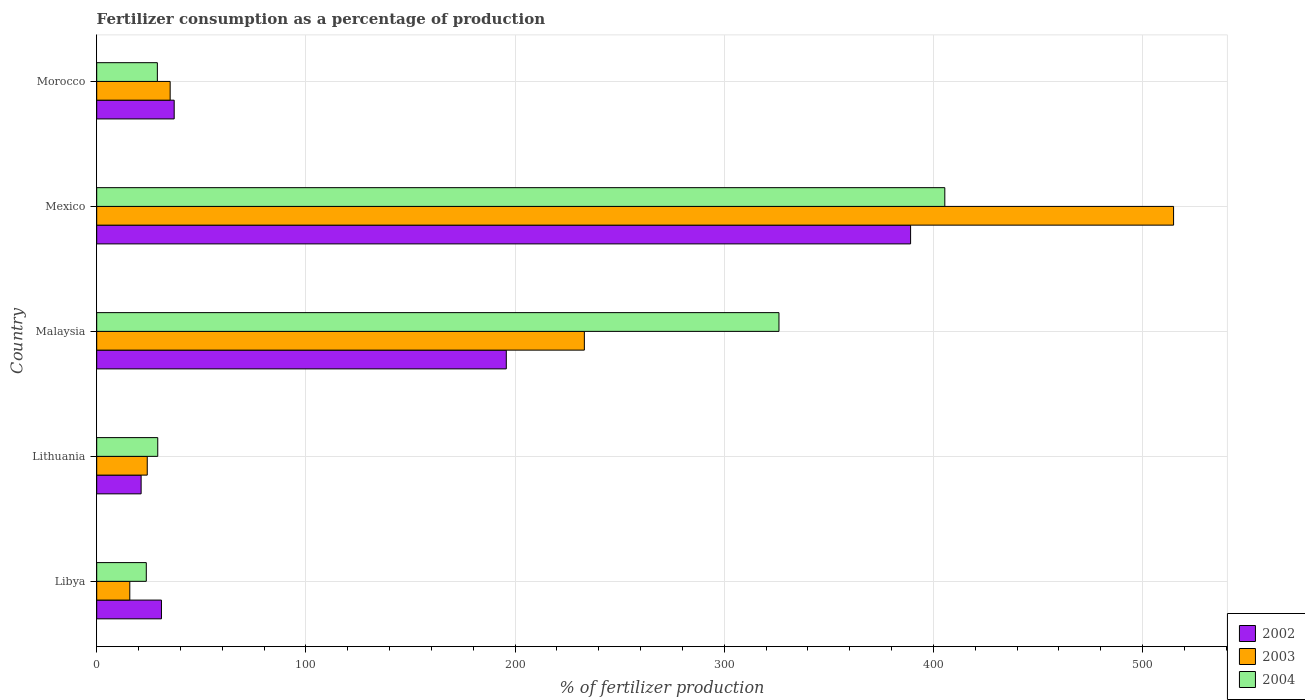Are the number of bars per tick equal to the number of legend labels?
Your response must be concise. Yes. How many bars are there on the 4th tick from the top?
Your response must be concise. 3. How many bars are there on the 3rd tick from the bottom?
Offer a terse response. 3. In how many cases, is the number of bars for a given country not equal to the number of legend labels?
Your response must be concise. 0. What is the percentage of fertilizers consumed in 2002 in Mexico?
Your response must be concise. 389.08. Across all countries, what is the maximum percentage of fertilizers consumed in 2002?
Your answer should be very brief. 389.08. Across all countries, what is the minimum percentage of fertilizers consumed in 2002?
Keep it short and to the point. 21.23. In which country was the percentage of fertilizers consumed in 2003 minimum?
Make the answer very short. Libya. What is the total percentage of fertilizers consumed in 2004 in the graph?
Provide a succinct answer. 813.48. What is the difference between the percentage of fertilizers consumed in 2003 in Lithuania and that in Malaysia?
Provide a succinct answer. -208.96. What is the difference between the percentage of fertilizers consumed in 2002 in Mexico and the percentage of fertilizers consumed in 2004 in Lithuania?
Your response must be concise. 359.9. What is the average percentage of fertilizers consumed in 2004 per country?
Your answer should be compact. 162.7. What is the difference between the percentage of fertilizers consumed in 2004 and percentage of fertilizers consumed in 2003 in Morocco?
Offer a very short reply. -6.12. In how many countries, is the percentage of fertilizers consumed in 2004 greater than 280 %?
Ensure brevity in your answer.  2. What is the ratio of the percentage of fertilizers consumed in 2002 in Lithuania to that in Malaysia?
Offer a terse response. 0.11. What is the difference between the highest and the second highest percentage of fertilizers consumed in 2002?
Your answer should be compact. 193.28. What is the difference between the highest and the lowest percentage of fertilizers consumed in 2004?
Provide a short and direct response. 381.73. In how many countries, is the percentage of fertilizers consumed in 2003 greater than the average percentage of fertilizers consumed in 2003 taken over all countries?
Provide a succinct answer. 2. What does the 2nd bar from the top in Lithuania represents?
Your response must be concise. 2003. Is it the case that in every country, the sum of the percentage of fertilizers consumed in 2002 and percentage of fertilizers consumed in 2003 is greater than the percentage of fertilizers consumed in 2004?
Your answer should be compact. Yes. How many bars are there?
Provide a succinct answer. 15. Are all the bars in the graph horizontal?
Your response must be concise. Yes. How many countries are there in the graph?
Keep it short and to the point. 5. What is the difference between two consecutive major ticks on the X-axis?
Provide a succinct answer. 100. Are the values on the major ticks of X-axis written in scientific E-notation?
Provide a succinct answer. No. Where does the legend appear in the graph?
Offer a terse response. Bottom right. How many legend labels are there?
Offer a terse response. 3. How are the legend labels stacked?
Ensure brevity in your answer.  Vertical. What is the title of the graph?
Offer a very short reply. Fertilizer consumption as a percentage of production. Does "1990" appear as one of the legend labels in the graph?
Provide a succinct answer. No. What is the label or title of the X-axis?
Make the answer very short. % of fertilizer production. What is the % of fertilizer production in 2002 in Libya?
Your answer should be compact. 30.95. What is the % of fertilizer production of 2003 in Libya?
Ensure brevity in your answer.  15.82. What is the % of fertilizer production in 2004 in Libya?
Make the answer very short. 23.71. What is the % of fertilizer production in 2002 in Lithuania?
Your answer should be very brief. 21.23. What is the % of fertilizer production of 2003 in Lithuania?
Give a very brief answer. 24.16. What is the % of fertilizer production of 2004 in Lithuania?
Offer a terse response. 29.18. What is the % of fertilizer production in 2002 in Malaysia?
Keep it short and to the point. 195.8. What is the % of fertilizer production in 2003 in Malaysia?
Your answer should be compact. 233.12. What is the % of fertilizer production in 2004 in Malaysia?
Make the answer very short. 326.16. What is the % of fertilizer production of 2002 in Mexico?
Offer a very short reply. 389.08. What is the % of fertilizer production of 2003 in Mexico?
Give a very brief answer. 514.81. What is the % of fertilizer production of 2004 in Mexico?
Your answer should be compact. 405.44. What is the % of fertilizer production in 2002 in Morocco?
Give a very brief answer. 37.04. What is the % of fertilizer production in 2003 in Morocco?
Your answer should be very brief. 35.11. What is the % of fertilizer production in 2004 in Morocco?
Offer a very short reply. 28.99. Across all countries, what is the maximum % of fertilizer production in 2002?
Make the answer very short. 389.08. Across all countries, what is the maximum % of fertilizer production in 2003?
Provide a succinct answer. 514.81. Across all countries, what is the maximum % of fertilizer production in 2004?
Your response must be concise. 405.44. Across all countries, what is the minimum % of fertilizer production in 2002?
Make the answer very short. 21.23. Across all countries, what is the minimum % of fertilizer production of 2003?
Keep it short and to the point. 15.82. Across all countries, what is the minimum % of fertilizer production in 2004?
Offer a very short reply. 23.71. What is the total % of fertilizer production of 2002 in the graph?
Provide a succinct answer. 674.11. What is the total % of fertilizer production in 2003 in the graph?
Offer a very short reply. 823.02. What is the total % of fertilizer production in 2004 in the graph?
Give a very brief answer. 813.48. What is the difference between the % of fertilizer production of 2002 in Libya and that in Lithuania?
Your answer should be very brief. 9.72. What is the difference between the % of fertilizer production in 2003 in Libya and that in Lithuania?
Provide a short and direct response. -8.35. What is the difference between the % of fertilizer production of 2004 in Libya and that in Lithuania?
Your answer should be very brief. -5.48. What is the difference between the % of fertilizer production in 2002 in Libya and that in Malaysia?
Provide a short and direct response. -164.85. What is the difference between the % of fertilizer production in 2003 in Libya and that in Malaysia?
Your response must be concise. -217.3. What is the difference between the % of fertilizer production of 2004 in Libya and that in Malaysia?
Make the answer very short. -302.45. What is the difference between the % of fertilizer production of 2002 in Libya and that in Mexico?
Give a very brief answer. -358.13. What is the difference between the % of fertilizer production in 2003 in Libya and that in Mexico?
Give a very brief answer. -498.99. What is the difference between the % of fertilizer production of 2004 in Libya and that in Mexico?
Ensure brevity in your answer.  -381.73. What is the difference between the % of fertilizer production of 2002 in Libya and that in Morocco?
Provide a short and direct response. -6.09. What is the difference between the % of fertilizer production of 2003 in Libya and that in Morocco?
Offer a terse response. -19.3. What is the difference between the % of fertilizer production of 2004 in Libya and that in Morocco?
Keep it short and to the point. -5.29. What is the difference between the % of fertilizer production of 2002 in Lithuania and that in Malaysia?
Provide a succinct answer. -174.57. What is the difference between the % of fertilizer production of 2003 in Lithuania and that in Malaysia?
Your answer should be compact. -208.96. What is the difference between the % of fertilizer production in 2004 in Lithuania and that in Malaysia?
Provide a succinct answer. -296.98. What is the difference between the % of fertilizer production in 2002 in Lithuania and that in Mexico?
Give a very brief answer. -367.85. What is the difference between the % of fertilizer production in 2003 in Lithuania and that in Mexico?
Keep it short and to the point. -490.64. What is the difference between the % of fertilizer production in 2004 in Lithuania and that in Mexico?
Keep it short and to the point. -376.26. What is the difference between the % of fertilizer production of 2002 in Lithuania and that in Morocco?
Ensure brevity in your answer.  -15.81. What is the difference between the % of fertilizer production of 2003 in Lithuania and that in Morocco?
Give a very brief answer. -10.95. What is the difference between the % of fertilizer production of 2004 in Lithuania and that in Morocco?
Ensure brevity in your answer.  0.19. What is the difference between the % of fertilizer production in 2002 in Malaysia and that in Mexico?
Make the answer very short. -193.28. What is the difference between the % of fertilizer production in 2003 in Malaysia and that in Mexico?
Give a very brief answer. -281.69. What is the difference between the % of fertilizer production in 2004 in Malaysia and that in Mexico?
Make the answer very short. -79.28. What is the difference between the % of fertilizer production of 2002 in Malaysia and that in Morocco?
Keep it short and to the point. 158.76. What is the difference between the % of fertilizer production of 2003 in Malaysia and that in Morocco?
Give a very brief answer. 198.01. What is the difference between the % of fertilizer production of 2004 in Malaysia and that in Morocco?
Offer a very short reply. 297.17. What is the difference between the % of fertilizer production in 2002 in Mexico and that in Morocco?
Your answer should be compact. 352.04. What is the difference between the % of fertilizer production in 2003 in Mexico and that in Morocco?
Offer a terse response. 479.69. What is the difference between the % of fertilizer production of 2004 in Mexico and that in Morocco?
Your answer should be compact. 376.45. What is the difference between the % of fertilizer production of 2002 in Libya and the % of fertilizer production of 2003 in Lithuania?
Provide a short and direct response. 6.79. What is the difference between the % of fertilizer production in 2002 in Libya and the % of fertilizer production in 2004 in Lithuania?
Ensure brevity in your answer.  1.77. What is the difference between the % of fertilizer production in 2003 in Libya and the % of fertilizer production in 2004 in Lithuania?
Give a very brief answer. -13.37. What is the difference between the % of fertilizer production of 2002 in Libya and the % of fertilizer production of 2003 in Malaysia?
Give a very brief answer. -202.17. What is the difference between the % of fertilizer production of 2002 in Libya and the % of fertilizer production of 2004 in Malaysia?
Provide a short and direct response. -295.2. What is the difference between the % of fertilizer production of 2003 in Libya and the % of fertilizer production of 2004 in Malaysia?
Offer a very short reply. -310.34. What is the difference between the % of fertilizer production in 2002 in Libya and the % of fertilizer production in 2003 in Mexico?
Provide a succinct answer. -483.85. What is the difference between the % of fertilizer production in 2002 in Libya and the % of fertilizer production in 2004 in Mexico?
Make the answer very short. -374.48. What is the difference between the % of fertilizer production in 2003 in Libya and the % of fertilizer production in 2004 in Mexico?
Offer a very short reply. -389.62. What is the difference between the % of fertilizer production of 2002 in Libya and the % of fertilizer production of 2003 in Morocco?
Make the answer very short. -4.16. What is the difference between the % of fertilizer production of 2002 in Libya and the % of fertilizer production of 2004 in Morocco?
Provide a succinct answer. 1.96. What is the difference between the % of fertilizer production of 2003 in Libya and the % of fertilizer production of 2004 in Morocco?
Make the answer very short. -13.18. What is the difference between the % of fertilizer production of 2002 in Lithuania and the % of fertilizer production of 2003 in Malaysia?
Your answer should be very brief. -211.89. What is the difference between the % of fertilizer production in 2002 in Lithuania and the % of fertilizer production in 2004 in Malaysia?
Make the answer very short. -304.93. What is the difference between the % of fertilizer production in 2003 in Lithuania and the % of fertilizer production in 2004 in Malaysia?
Ensure brevity in your answer.  -302. What is the difference between the % of fertilizer production of 2002 in Lithuania and the % of fertilizer production of 2003 in Mexico?
Give a very brief answer. -493.57. What is the difference between the % of fertilizer production of 2002 in Lithuania and the % of fertilizer production of 2004 in Mexico?
Give a very brief answer. -384.21. What is the difference between the % of fertilizer production in 2003 in Lithuania and the % of fertilizer production in 2004 in Mexico?
Provide a short and direct response. -381.28. What is the difference between the % of fertilizer production in 2002 in Lithuania and the % of fertilizer production in 2003 in Morocco?
Provide a succinct answer. -13.88. What is the difference between the % of fertilizer production of 2002 in Lithuania and the % of fertilizer production of 2004 in Morocco?
Provide a short and direct response. -7.76. What is the difference between the % of fertilizer production of 2003 in Lithuania and the % of fertilizer production of 2004 in Morocco?
Make the answer very short. -4.83. What is the difference between the % of fertilizer production in 2002 in Malaysia and the % of fertilizer production in 2003 in Mexico?
Offer a very short reply. -319. What is the difference between the % of fertilizer production in 2002 in Malaysia and the % of fertilizer production in 2004 in Mexico?
Your answer should be compact. -209.64. What is the difference between the % of fertilizer production in 2003 in Malaysia and the % of fertilizer production in 2004 in Mexico?
Offer a terse response. -172.32. What is the difference between the % of fertilizer production in 2002 in Malaysia and the % of fertilizer production in 2003 in Morocco?
Provide a succinct answer. 160.69. What is the difference between the % of fertilizer production of 2002 in Malaysia and the % of fertilizer production of 2004 in Morocco?
Keep it short and to the point. 166.81. What is the difference between the % of fertilizer production in 2003 in Malaysia and the % of fertilizer production in 2004 in Morocco?
Provide a succinct answer. 204.13. What is the difference between the % of fertilizer production of 2002 in Mexico and the % of fertilizer production of 2003 in Morocco?
Offer a very short reply. 353.97. What is the difference between the % of fertilizer production of 2002 in Mexico and the % of fertilizer production of 2004 in Morocco?
Ensure brevity in your answer.  360.09. What is the difference between the % of fertilizer production in 2003 in Mexico and the % of fertilizer production in 2004 in Morocco?
Your answer should be compact. 485.81. What is the average % of fertilizer production in 2002 per country?
Provide a succinct answer. 134.82. What is the average % of fertilizer production in 2003 per country?
Your answer should be compact. 164.6. What is the average % of fertilizer production of 2004 per country?
Make the answer very short. 162.7. What is the difference between the % of fertilizer production of 2002 and % of fertilizer production of 2003 in Libya?
Your answer should be very brief. 15.14. What is the difference between the % of fertilizer production in 2002 and % of fertilizer production in 2004 in Libya?
Your answer should be compact. 7.25. What is the difference between the % of fertilizer production of 2003 and % of fertilizer production of 2004 in Libya?
Keep it short and to the point. -7.89. What is the difference between the % of fertilizer production of 2002 and % of fertilizer production of 2003 in Lithuania?
Give a very brief answer. -2.93. What is the difference between the % of fertilizer production in 2002 and % of fertilizer production in 2004 in Lithuania?
Provide a short and direct response. -7.95. What is the difference between the % of fertilizer production in 2003 and % of fertilizer production in 2004 in Lithuania?
Provide a succinct answer. -5.02. What is the difference between the % of fertilizer production of 2002 and % of fertilizer production of 2003 in Malaysia?
Give a very brief answer. -37.32. What is the difference between the % of fertilizer production of 2002 and % of fertilizer production of 2004 in Malaysia?
Ensure brevity in your answer.  -130.36. What is the difference between the % of fertilizer production in 2003 and % of fertilizer production in 2004 in Malaysia?
Your answer should be very brief. -93.04. What is the difference between the % of fertilizer production in 2002 and % of fertilizer production in 2003 in Mexico?
Your answer should be very brief. -125.73. What is the difference between the % of fertilizer production in 2002 and % of fertilizer production in 2004 in Mexico?
Your response must be concise. -16.36. What is the difference between the % of fertilizer production in 2003 and % of fertilizer production in 2004 in Mexico?
Ensure brevity in your answer.  109.37. What is the difference between the % of fertilizer production in 2002 and % of fertilizer production in 2003 in Morocco?
Provide a succinct answer. 1.93. What is the difference between the % of fertilizer production in 2002 and % of fertilizer production in 2004 in Morocco?
Make the answer very short. 8.05. What is the difference between the % of fertilizer production in 2003 and % of fertilizer production in 2004 in Morocco?
Keep it short and to the point. 6.12. What is the ratio of the % of fertilizer production in 2002 in Libya to that in Lithuania?
Your answer should be very brief. 1.46. What is the ratio of the % of fertilizer production of 2003 in Libya to that in Lithuania?
Provide a short and direct response. 0.65. What is the ratio of the % of fertilizer production of 2004 in Libya to that in Lithuania?
Your response must be concise. 0.81. What is the ratio of the % of fertilizer production in 2002 in Libya to that in Malaysia?
Provide a succinct answer. 0.16. What is the ratio of the % of fertilizer production in 2003 in Libya to that in Malaysia?
Ensure brevity in your answer.  0.07. What is the ratio of the % of fertilizer production in 2004 in Libya to that in Malaysia?
Offer a terse response. 0.07. What is the ratio of the % of fertilizer production of 2002 in Libya to that in Mexico?
Provide a short and direct response. 0.08. What is the ratio of the % of fertilizer production of 2003 in Libya to that in Mexico?
Make the answer very short. 0.03. What is the ratio of the % of fertilizer production of 2004 in Libya to that in Mexico?
Provide a succinct answer. 0.06. What is the ratio of the % of fertilizer production in 2002 in Libya to that in Morocco?
Provide a short and direct response. 0.84. What is the ratio of the % of fertilizer production in 2003 in Libya to that in Morocco?
Keep it short and to the point. 0.45. What is the ratio of the % of fertilizer production in 2004 in Libya to that in Morocco?
Make the answer very short. 0.82. What is the ratio of the % of fertilizer production in 2002 in Lithuania to that in Malaysia?
Ensure brevity in your answer.  0.11. What is the ratio of the % of fertilizer production of 2003 in Lithuania to that in Malaysia?
Offer a very short reply. 0.1. What is the ratio of the % of fertilizer production of 2004 in Lithuania to that in Malaysia?
Provide a short and direct response. 0.09. What is the ratio of the % of fertilizer production in 2002 in Lithuania to that in Mexico?
Keep it short and to the point. 0.05. What is the ratio of the % of fertilizer production in 2003 in Lithuania to that in Mexico?
Offer a very short reply. 0.05. What is the ratio of the % of fertilizer production of 2004 in Lithuania to that in Mexico?
Your response must be concise. 0.07. What is the ratio of the % of fertilizer production of 2002 in Lithuania to that in Morocco?
Offer a terse response. 0.57. What is the ratio of the % of fertilizer production in 2003 in Lithuania to that in Morocco?
Give a very brief answer. 0.69. What is the ratio of the % of fertilizer production in 2004 in Lithuania to that in Morocco?
Provide a short and direct response. 1.01. What is the ratio of the % of fertilizer production of 2002 in Malaysia to that in Mexico?
Ensure brevity in your answer.  0.5. What is the ratio of the % of fertilizer production of 2003 in Malaysia to that in Mexico?
Provide a short and direct response. 0.45. What is the ratio of the % of fertilizer production in 2004 in Malaysia to that in Mexico?
Provide a succinct answer. 0.8. What is the ratio of the % of fertilizer production in 2002 in Malaysia to that in Morocco?
Offer a very short reply. 5.29. What is the ratio of the % of fertilizer production in 2003 in Malaysia to that in Morocco?
Your answer should be compact. 6.64. What is the ratio of the % of fertilizer production in 2004 in Malaysia to that in Morocco?
Provide a succinct answer. 11.25. What is the ratio of the % of fertilizer production in 2002 in Mexico to that in Morocco?
Ensure brevity in your answer.  10.5. What is the ratio of the % of fertilizer production of 2003 in Mexico to that in Morocco?
Your answer should be very brief. 14.66. What is the ratio of the % of fertilizer production of 2004 in Mexico to that in Morocco?
Keep it short and to the point. 13.98. What is the difference between the highest and the second highest % of fertilizer production of 2002?
Ensure brevity in your answer.  193.28. What is the difference between the highest and the second highest % of fertilizer production in 2003?
Offer a terse response. 281.69. What is the difference between the highest and the second highest % of fertilizer production of 2004?
Provide a succinct answer. 79.28. What is the difference between the highest and the lowest % of fertilizer production in 2002?
Make the answer very short. 367.85. What is the difference between the highest and the lowest % of fertilizer production in 2003?
Your answer should be very brief. 498.99. What is the difference between the highest and the lowest % of fertilizer production of 2004?
Your response must be concise. 381.73. 